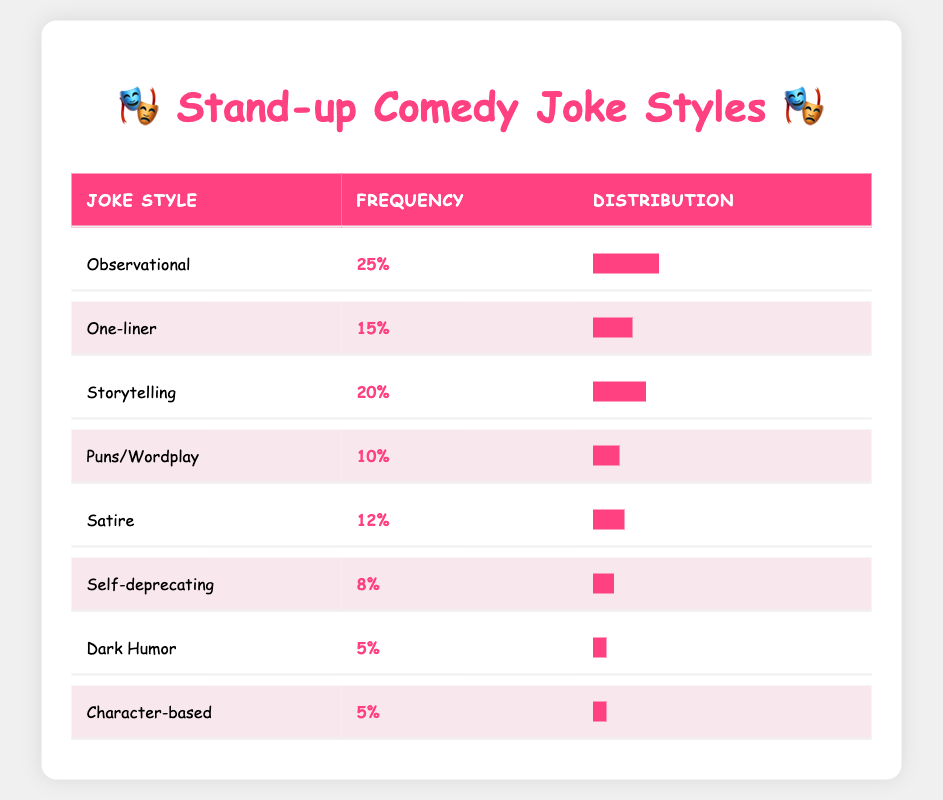What is the most frequently used joke style in stand-up routines? The table shows that the "Observational" joke style has the highest frequency at 25%. Therefore, it is the most frequently used style.
Answer: Observational How many joke styles have a frequency of 10% or less? From the table, the joke styles that have a frequency of 10% or less are "Puns/Wordplay" (10%), "Self-deprecating" (8%), "Dark Humor" (5%), and "Character-based" (5%). This gives us a total of four joke styles.
Answer: 4 Is "Self-deprecating" more frequently used than "Dark Humor"? According to the table, "Self-deprecating" has a frequency of 8%, while "Dark Humor" has a frequency of 5%. Since 8% is greater than 5%, "Self-deprecating" is indeed used more frequently.
Answer: Yes What is the total frequency percentage of "Storytelling" and "Satire" combined? The frequency of "Storytelling" is 20% and "Satire" is 12%. Adding these together gives us 20% + 12% = 32%. Therefore, the total frequency percentage for these two styles combined is 32%.
Answer: 32% Which joke style has a frequency closest to the average frequency of all styles? First, we need to calculate the average frequency. The sum of all frequencies is 25 + 15 + 20 + 10 + 12 + 8 + 5 + 5 = 105. There are 8 joke styles, so the average is 105 / 8 = 13.125%. The closest frequency to this average is "Satire" at 12% and "One-liner" at 15%, but "One-liner" is closer.
Answer: One-liner 